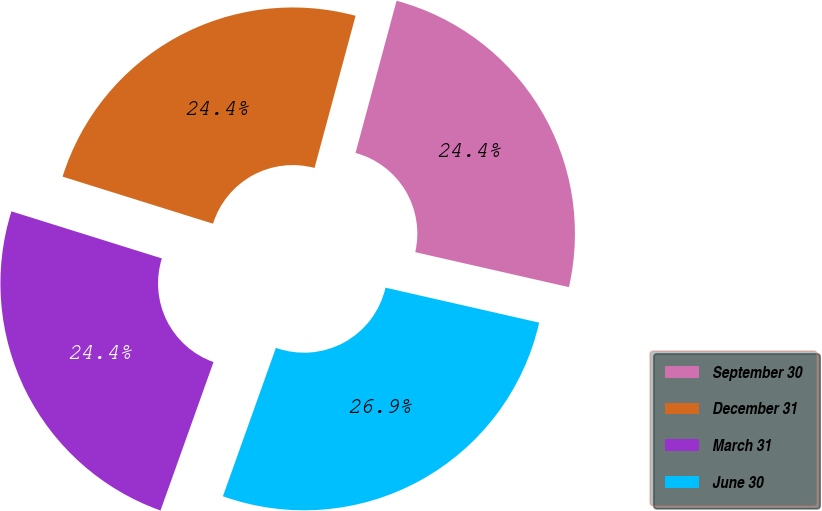<chart> <loc_0><loc_0><loc_500><loc_500><pie_chart><fcel>September 30<fcel>December 31<fcel>March 31<fcel>June 30<nl><fcel>24.37%<fcel>24.37%<fcel>24.37%<fcel>26.9%<nl></chart> 